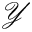<formula> <loc_0><loc_0><loc_500><loc_500>\mathcal { Y }</formula> 